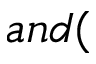Convert formula to latex. <formula><loc_0><loc_0><loc_500><loc_500>a n d (</formula> 